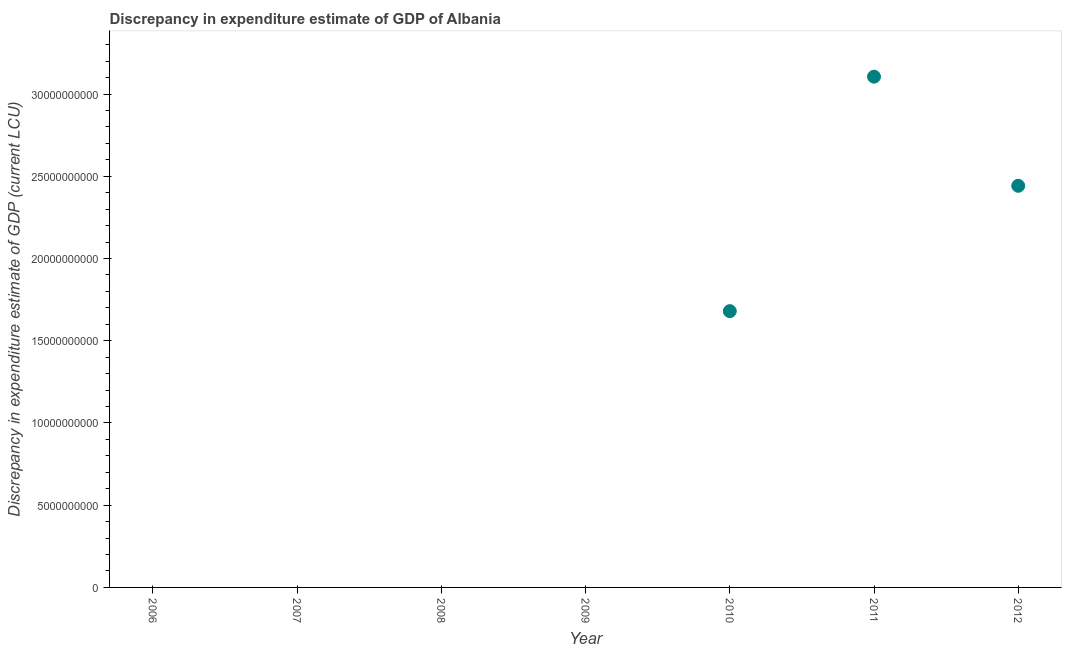What is the discrepancy in expenditure estimate of gdp in 2010?
Give a very brief answer. 1.68e+1. Across all years, what is the maximum discrepancy in expenditure estimate of gdp?
Keep it short and to the point. 3.11e+1. In which year was the discrepancy in expenditure estimate of gdp maximum?
Your answer should be very brief. 2011. What is the sum of the discrepancy in expenditure estimate of gdp?
Offer a very short reply. 7.23e+1. What is the difference between the discrepancy in expenditure estimate of gdp in 2010 and 2011?
Your response must be concise. -1.43e+1. What is the average discrepancy in expenditure estimate of gdp per year?
Provide a short and direct response. 1.03e+1. What is the median discrepancy in expenditure estimate of gdp?
Provide a succinct answer. 0. In how many years, is the discrepancy in expenditure estimate of gdp greater than 19000000000 LCU?
Ensure brevity in your answer.  2. What is the difference between the highest and the second highest discrepancy in expenditure estimate of gdp?
Make the answer very short. 6.64e+09. Is the sum of the discrepancy in expenditure estimate of gdp in 2010 and 2012 greater than the maximum discrepancy in expenditure estimate of gdp across all years?
Provide a succinct answer. Yes. What is the difference between the highest and the lowest discrepancy in expenditure estimate of gdp?
Give a very brief answer. 3.11e+1. How many dotlines are there?
Your answer should be very brief. 1. How many years are there in the graph?
Give a very brief answer. 7. What is the difference between two consecutive major ticks on the Y-axis?
Ensure brevity in your answer.  5.00e+09. Are the values on the major ticks of Y-axis written in scientific E-notation?
Ensure brevity in your answer.  No. Does the graph contain any zero values?
Your response must be concise. Yes. What is the title of the graph?
Offer a very short reply. Discrepancy in expenditure estimate of GDP of Albania. What is the label or title of the X-axis?
Offer a very short reply. Year. What is the label or title of the Y-axis?
Keep it short and to the point. Discrepancy in expenditure estimate of GDP (current LCU). What is the Discrepancy in expenditure estimate of GDP (current LCU) in 2006?
Offer a very short reply. 0. What is the Discrepancy in expenditure estimate of GDP (current LCU) in 2009?
Your answer should be compact. 0. What is the Discrepancy in expenditure estimate of GDP (current LCU) in 2010?
Provide a short and direct response. 1.68e+1. What is the Discrepancy in expenditure estimate of GDP (current LCU) in 2011?
Provide a succinct answer. 3.11e+1. What is the Discrepancy in expenditure estimate of GDP (current LCU) in 2012?
Make the answer very short. 2.44e+1. What is the difference between the Discrepancy in expenditure estimate of GDP (current LCU) in 2010 and 2011?
Make the answer very short. -1.43e+1. What is the difference between the Discrepancy in expenditure estimate of GDP (current LCU) in 2010 and 2012?
Offer a terse response. -7.62e+09. What is the difference between the Discrepancy in expenditure estimate of GDP (current LCU) in 2011 and 2012?
Your answer should be compact. 6.64e+09. What is the ratio of the Discrepancy in expenditure estimate of GDP (current LCU) in 2010 to that in 2011?
Offer a terse response. 0.54. What is the ratio of the Discrepancy in expenditure estimate of GDP (current LCU) in 2010 to that in 2012?
Offer a terse response. 0.69. What is the ratio of the Discrepancy in expenditure estimate of GDP (current LCU) in 2011 to that in 2012?
Provide a succinct answer. 1.27. 